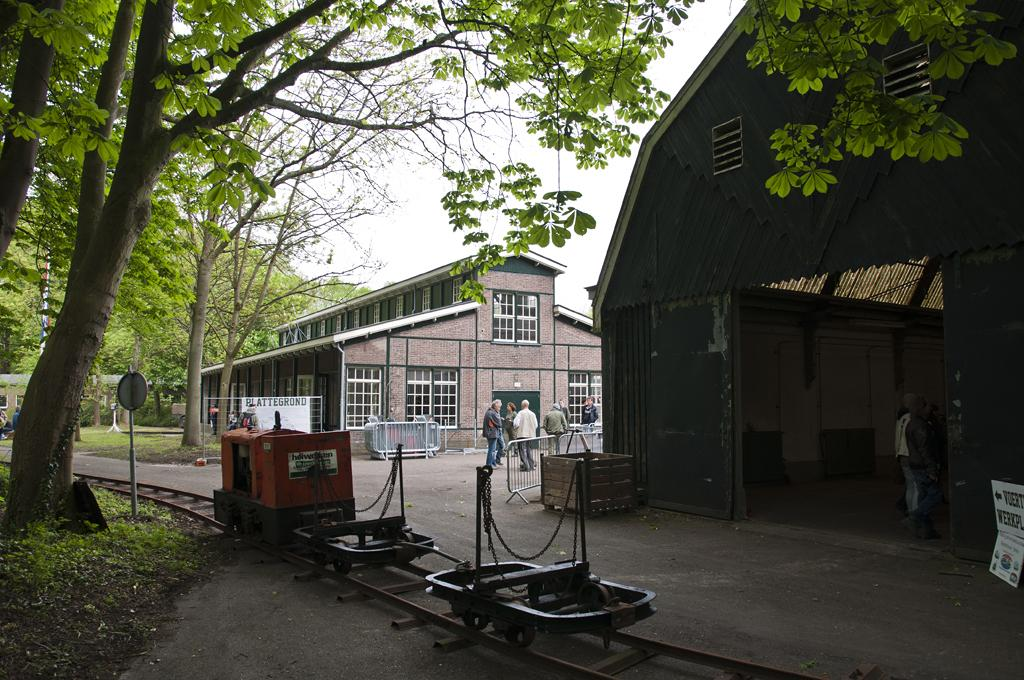What type of structures can be seen in the image? There are buildings in the image. What architectural features can be observed on the buildings? Windows are visible in the image. What additional structure is present in the image? There is a shed in the image. What type of natural elements are present in the image? Trees are present in the image. Are there any human figures in the image? Yes, there are people in the image. What type of signage is visible in the image? There are sign boards in the image. What other objects can be seen in the image? Poles are visible in the image. What can be seen in the sky in the image? The sky is visible in the image. What type of objects are on a track in the image? There are objects on a track in the image. How many owls can be seen in the image? There are no owls present in the image. What type of woman is depicted in the image? There is no specific woman depicted in the image; it features buildings, trees, people, and other objects. 